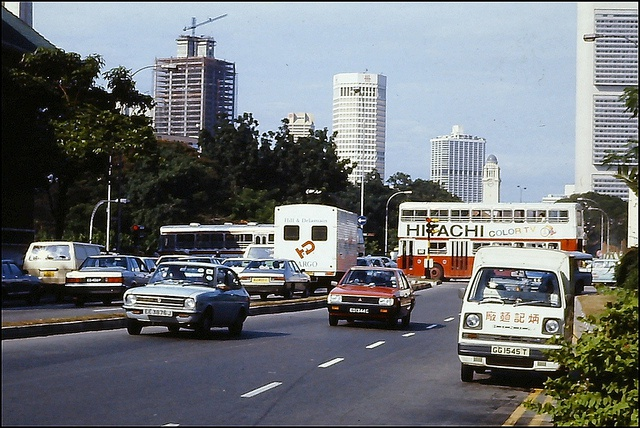Describe the objects in this image and their specific colors. I can see truck in black, ivory, gray, and darkgray tones, bus in black, white, darkgray, and gray tones, car in black, lightgray, gray, and darkgray tones, truck in black, white, darkgray, and gray tones, and car in black, lightgray, darkgray, and gray tones in this image. 